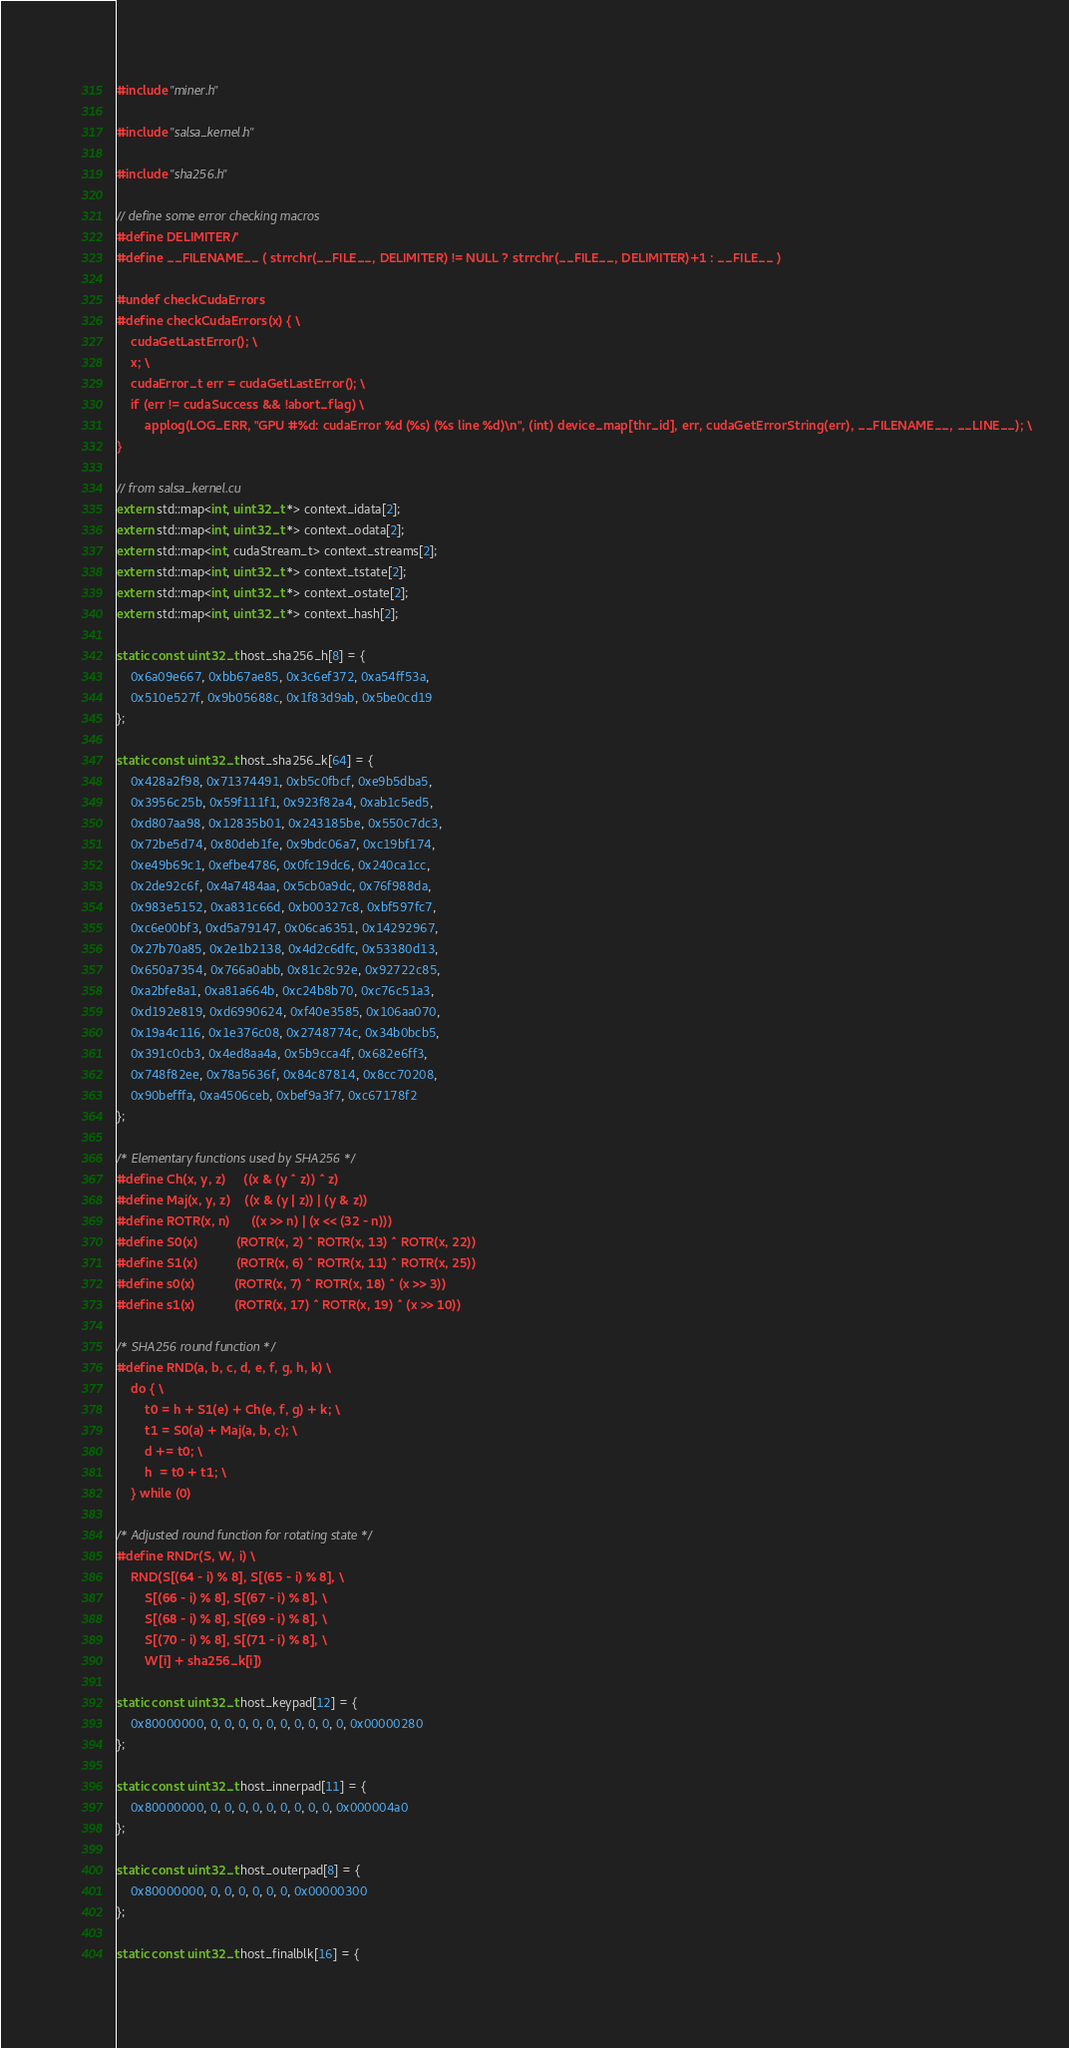<code> <loc_0><loc_0><loc_500><loc_500><_Cuda_>#include "miner.h"

#include "salsa_kernel.h"

#include "sha256.h"

// define some error checking macros
#define DELIMITER '/'
#define __FILENAME__ ( strrchr(__FILE__, DELIMITER) != NULL ? strrchr(__FILE__, DELIMITER)+1 : __FILE__ )

#undef checkCudaErrors
#define checkCudaErrors(x) { \
	cudaGetLastError(); \
	x; \
	cudaError_t err = cudaGetLastError(); \
	if (err != cudaSuccess && !abort_flag) \
		applog(LOG_ERR, "GPU #%d: cudaError %d (%s) (%s line %d)\n", (int) device_map[thr_id], err, cudaGetErrorString(err), __FILENAME__, __LINE__); \
}

// from salsa_kernel.cu
extern std::map<int, uint32_t *> context_idata[2];
extern std::map<int, uint32_t *> context_odata[2];
extern std::map<int, cudaStream_t> context_streams[2];
extern std::map<int, uint32_t *> context_tstate[2];
extern std::map<int, uint32_t *> context_ostate[2];
extern std::map<int, uint32_t *> context_hash[2];

static const uint32_t host_sha256_h[8] = {
	0x6a09e667, 0xbb67ae85, 0x3c6ef372, 0xa54ff53a,
	0x510e527f, 0x9b05688c, 0x1f83d9ab, 0x5be0cd19
};

static const uint32_t host_sha256_k[64] = {
	0x428a2f98, 0x71374491, 0xb5c0fbcf, 0xe9b5dba5,
	0x3956c25b, 0x59f111f1, 0x923f82a4, 0xab1c5ed5,
	0xd807aa98, 0x12835b01, 0x243185be, 0x550c7dc3,
	0x72be5d74, 0x80deb1fe, 0x9bdc06a7, 0xc19bf174,
	0xe49b69c1, 0xefbe4786, 0x0fc19dc6, 0x240ca1cc,
	0x2de92c6f, 0x4a7484aa, 0x5cb0a9dc, 0x76f988da,
	0x983e5152, 0xa831c66d, 0xb00327c8, 0xbf597fc7,
	0xc6e00bf3, 0xd5a79147, 0x06ca6351, 0x14292967,
	0x27b70a85, 0x2e1b2138, 0x4d2c6dfc, 0x53380d13,
	0x650a7354, 0x766a0abb, 0x81c2c92e, 0x92722c85,
	0xa2bfe8a1, 0xa81a664b, 0xc24b8b70, 0xc76c51a3,
	0xd192e819, 0xd6990624, 0xf40e3585, 0x106aa070,
	0x19a4c116, 0x1e376c08, 0x2748774c, 0x34b0bcb5,
	0x391c0cb3, 0x4ed8aa4a, 0x5b9cca4f, 0x682e6ff3,
	0x748f82ee, 0x78a5636f, 0x84c87814, 0x8cc70208,
	0x90befffa, 0xa4506ceb, 0xbef9a3f7, 0xc67178f2
};

/* Elementary functions used by SHA256 */
#define Ch(x, y, z)     ((x & (y ^ z)) ^ z)
#define Maj(x, y, z)    ((x & (y | z)) | (y & z))
#define ROTR(x, n)      ((x >> n) | (x << (32 - n)))
#define S0(x)           (ROTR(x, 2) ^ ROTR(x, 13) ^ ROTR(x, 22))
#define S1(x)           (ROTR(x, 6) ^ ROTR(x, 11) ^ ROTR(x, 25))
#define s0(x)           (ROTR(x, 7) ^ ROTR(x, 18) ^ (x >> 3))
#define s1(x)           (ROTR(x, 17) ^ ROTR(x, 19) ^ (x >> 10))

/* SHA256 round function */
#define RND(a, b, c, d, e, f, g, h, k) \
	do { \
		t0 = h + S1(e) + Ch(e, f, g) + k; \
		t1 = S0(a) + Maj(a, b, c); \
		d += t0; \
		h  = t0 + t1; \
	} while (0)

/* Adjusted round function for rotating state */
#define RNDr(S, W, i) \
	RND(S[(64 - i) % 8], S[(65 - i) % 8], \
		S[(66 - i) % 8], S[(67 - i) % 8], \
		S[(68 - i) % 8], S[(69 - i) % 8], \
		S[(70 - i) % 8], S[(71 - i) % 8], \
		W[i] + sha256_k[i])

static const uint32_t host_keypad[12] = {
	0x80000000, 0, 0, 0, 0, 0, 0, 0, 0, 0, 0, 0x00000280
};

static const uint32_t host_innerpad[11] = {
	0x80000000, 0, 0, 0, 0, 0, 0, 0, 0, 0, 0x000004a0
};

static const uint32_t host_outerpad[8] = {
	0x80000000, 0, 0, 0, 0, 0, 0, 0x00000300
};

static const uint32_t host_finalblk[16] = {</code> 